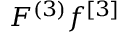Convert formula to latex. <formula><loc_0><loc_0><loc_500><loc_500>F ^ { ( 3 ) } f ^ { [ 3 ] }</formula> 